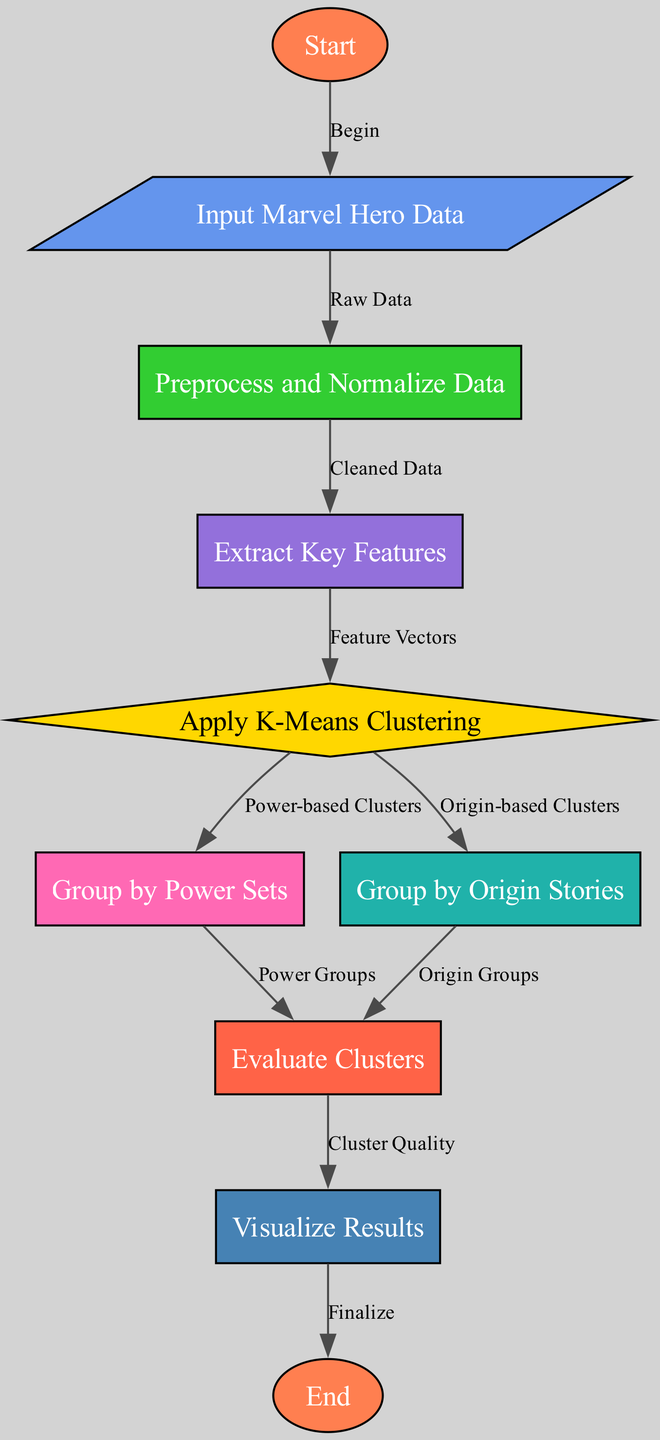What is the first step in the clustering algorithm? The first step in the diagram is labeled as "Start", which indicates the beginning of the clustering process. From the "Start" node, the next step is to "Input Marvel Hero Data".
Answer: Start How many nodes are there in the diagram? To find the total number of nodes, we can count them in the data provided. There are 10 nodes including Start and End, as well as input, preprocess, feature extraction, and others.
Answer: 10 Which node evaluates the clusters created by the algorithm? The node that evaluates the clusters is labeled "Evaluate Clusters". It receives inputs from the "Group by Power Sets" and "Group by Origin Stories" nodes.
Answer: Evaluate Clusters What is the relationship between the "Apply K-Means Clustering" and "Group by Power Sets"? The "Apply K-Means Clustering" node directly leads to the "Group by Power Sets" node, meaning that after applying the K-Means algorithm, the next logical step is to group the heroes by their power sets.
Answer: Leads to Which node follows "Extract Key Features"? The node that follows "Extract Key Features" is "Apply K-Means Clustering". This indicates the flow from feature extraction to the application of the K-Means algorithm for clustering purposes.
Answer: Apply K-Means Clustering What type of clusters are generated from the "Apply K-Means Clustering"? The nodes that are generated from "Apply K-Means Clustering" include "Group by Power Sets" and "Group by Origin Stories". Thus, the clusters generated are power-based clusters and origin-based clusters.
Answer: Power-based Clusters, Origin-based Clusters What is the final step before completing the clustering algorithm? The final step before completing the algorithm is "Visualize Results". This node presents the output of the clustering evaluation, which is visualized before reaching the "End" node.
Answer: Visualize Results Which node do both "Group by Power Sets" and "Group by Origin Stories" lead to? Both "Group by Power Sets" and "Group by Origin Stories" lead to the "Evaluate Clusters" node, indicating that both types of clustering are assessed together.
Answer: Evaluate Clusters How do we define the quality of clusters in this algorithm? The quality of the clusters is evaluated in the "Evaluate Clusters" node, determining how well the clusters formed during clustering meet certain criteria.
Answer: Evaluate Clusters 